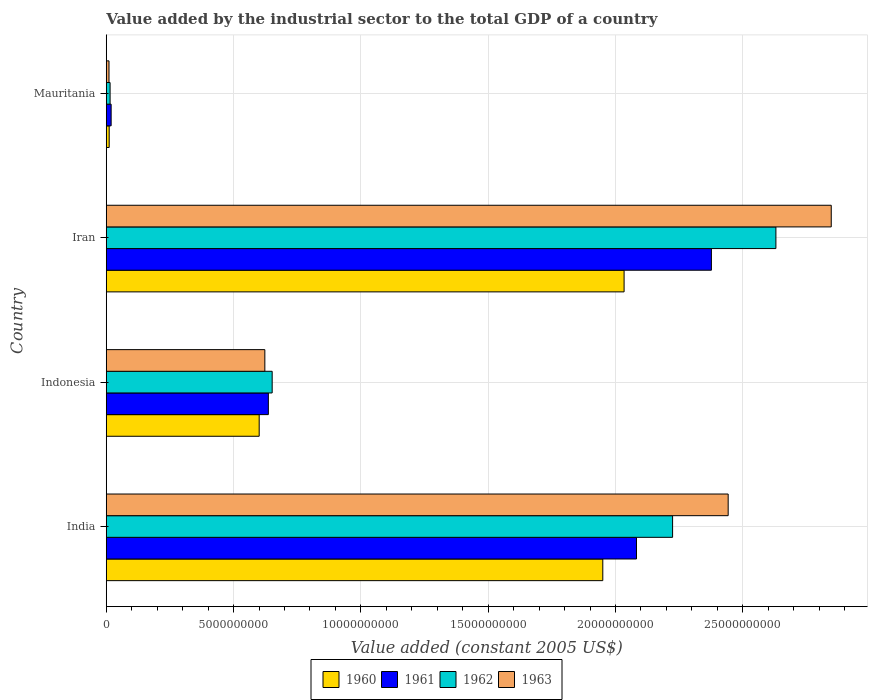Are the number of bars per tick equal to the number of legend labels?
Your response must be concise. Yes. How many bars are there on the 3rd tick from the top?
Offer a terse response. 4. How many bars are there on the 3rd tick from the bottom?
Ensure brevity in your answer.  4. What is the label of the 2nd group of bars from the top?
Give a very brief answer. Iran. In how many cases, is the number of bars for a given country not equal to the number of legend labels?
Ensure brevity in your answer.  0. What is the value added by the industrial sector in 1960 in Indonesia?
Make the answer very short. 6.01e+09. Across all countries, what is the maximum value added by the industrial sector in 1961?
Give a very brief answer. 2.38e+1. Across all countries, what is the minimum value added by the industrial sector in 1961?
Give a very brief answer. 1.92e+08. In which country was the value added by the industrial sector in 1960 maximum?
Your response must be concise. Iran. In which country was the value added by the industrial sector in 1962 minimum?
Offer a very short reply. Mauritania. What is the total value added by the industrial sector in 1962 in the graph?
Offer a very short reply. 5.52e+1. What is the difference between the value added by the industrial sector in 1960 in Indonesia and that in Iran?
Offer a very short reply. -1.43e+1. What is the difference between the value added by the industrial sector in 1960 in India and the value added by the industrial sector in 1963 in Mauritania?
Provide a succinct answer. 1.94e+1. What is the average value added by the industrial sector in 1961 per country?
Make the answer very short. 1.28e+1. What is the difference between the value added by the industrial sector in 1963 and value added by the industrial sector in 1960 in Indonesia?
Your response must be concise. 2.22e+08. In how many countries, is the value added by the industrial sector in 1963 greater than 21000000000 US$?
Your response must be concise. 2. What is the ratio of the value added by the industrial sector in 1962 in Iran to that in Mauritania?
Ensure brevity in your answer.  173.84. Is the difference between the value added by the industrial sector in 1963 in India and Indonesia greater than the difference between the value added by the industrial sector in 1960 in India and Indonesia?
Your answer should be very brief. Yes. What is the difference between the highest and the second highest value added by the industrial sector in 1963?
Make the answer very short. 4.05e+09. What is the difference between the highest and the lowest value added by the industrial sector in 1962?
Your response must be concise. 2.62e+1. In how many countries, is the value added by the industrial sector in 1963 greater than the average value added by the industrial sector in 1963 taken over all countries?
Your response must be concise. 2. Is the sum of the value added by the industrial sector in 1963 in India and Indonesia greater than the maximum value added by the industrial sector in 1961 across all countries?
Provide a short and direct response. Yes. What does the 3rd bar from the top in Indonesia represents?
Keep it short and to the point. 1961. Is it the case that in every country, the sum of the value added by the industrial sector in 1963 and value added by the industrial sector in 1961 is greater than the value added by the industrial sector in 1960?
Offer a terse response. Yes. How many countries are there in the graph?
Give a very brief answer. 4. Are the values on the major ticks of X-axis written in scientific E-notation?
Offer a terse response. No. Where does the legend appear in the graph?
Offer a terse response. Bottom center. What is the title of the graph?
Make the answer very short. Value added by the industrial sector to the total GDP of a country. What is the label or title of the X-axis?
Your answer should be very brief. Value added (constant 2005 US$). What is the Value added (constant 2005 US$) in 1960 in India?
Ensure brevity in your answer.  1.95e+1. What is the Value added (constant 2005 US$) in 1961 in India?
Offer a very short reply. 2.08e+1. What is the Value added (constant 2005 US$) in 1962 in India?
Ensure brevity in your answer.  2.22e+1. What is the Value added (constant 2005 US$) in 1963 in India?
Make the answer very short. 2.44e+1. What is the Value added (constant 2005 US$) in 1960 in Indonesia?
Keep it short and to the point. 6.01e+09. What is the Value added (constant 2005 US$) in 1961 in Indonesia?
Provide a succinct answer. 6.37e+09. What is the Value added (constant 2005 US$) in 1962 in Indonesia?
Offer a very short reply. 6.52e+09. What is the Value added (constant 2005 US$) in 1963 in Indonesia?
Keep it short and to the point. 6.23e+09. What is the Value added (constant 2005 US$) of 1960 in Iran?
Offer a very short reply. 2.03e+1. What is the Value added (constant 2005 US$) in 1961 in Iran?
Provide a short and direct response. 2.38e+1. What is the Value added (constant 2005 US$) in 1962 in Iran?
Offer a very short reply. 2.63e+1. What is the Value added (constant 2005 US$) in 1963 in Iran?
Give a very brief answer. 2.85e+1. What is the Value added (constant 2005 US$) of 1960 in Mauritania?
Your response must be concise. 1.15e+08. What is the Value added (constant 2005 US$) in 1961 in Mauritania?
Your answer should be compact. 1.92e+08. What is the Value added (constant 2005 US$) of 1962 in Mauritania?
Ensure brevity in your answer.  1.51e+08. What is the Value added (constant 2005 US$) of 1963 in Mauritania?
Offer a terse response. 1.08e+08. Across all countries, what is the maximum Value added (constant 2005 US$) in 1960?
Offer a very short reply. 2.03e+1. Across all countries, what is the maximum Value added (constant 2005 US$) of 1961?
Offer a very short reply. 2.38e+1. Across all countries, what is the maximum Value added (constant 2005 US$) in 1962?
Provide a short and direct response. 2.63e+1. Across all countries, what is the maximum Value added (constant 2005 US$) in 1963?
Offer a terse response. 2.85e+1. Across all countries, what is the minimum Value added (constant 2005 US$) of 1960?
Your answer should be compact. 1.15e+08. Across all countries, what is the minimum Value added (constant 2005 US$) in 1961?
Keep it short and to the point. 1.92e+08. Across all countries, what is the minimum Value added (constant 2005 US$) in 1962?
Your response must be concise. 1.51e+08. Across all countries, what is the minimum Value added (constant 2005 US$) of 1963?
Make the answer very short. 1.08e+08. What is the total Value added (constant 2005 US$) in 1960 in the graph?
Provide a succinct answer. 4.60e+1. What is the total Value added (constant 2005 US$) of 1961 in the graph?
Give a very brief answer. 5.12e+1. What is the total Value added (constant 2005 US$) in 1962 in the graph?
Ensure brevity in your answer.  5.52e+1. What is the total Value added (constant 2005 US$) of 1963 in the graph?
Your response must be concise. 5.92e+1. What is the difference between the Value added (constant 2005 US$) in 1960 in India and that in Indonesia?
Offer a very short reply. 1.35e+1. What is the difference between the Value added (constant 2005 US$) in 1961 in India and that in Indonesia?
Your answer should be compact. 1.45e+1. What is the difference between the Value added (constant 2005 US$) of 1962 in India and that in Indonesia?
Your response must be concise. 1.57e+1. What is the difference between the Value added (constant 2005 US$) in 1963 in India and that in Indonesia?
Provide a succinct answer. 1.82e+1. What is the difference between the Value added (constant 2005 US$) in 1960 in India and that in Iran?
Give a very brief answer. -8.36e+08. What is the difference between the Value added (constant 2005 US$) in 1961 in India and that in Iran?
Your response must be concise. -2.94e+09. What is the difference between the Value added (constant 2005 US$) of 1962 in India and that in Iran?
Offer a terse response. -4.06e+09. What is the difference between the Value added (constant 2005 US$) of 1963 in India and that in Iran?
Offer a terse response. -4.05e+09. What is the difference between the Value added (constant 2005 US$) of 1960 in India and that in Mauritania?
Provide a succinct answer. 1.94e+1. What is the difference between the Value added (constant 2005 US$) of 1961 in India and that in Mauritania?
Offer a very short reply. 2.06e+1. What is the difference between the Value added (constant 2005 US$) in 1962 in India and that in Mauritania?
Provide a succinct answer. 2.21e+1. What is the difference between the Value added (constant 2005 US$) in 1963 in India and that in Mauritania?
Make the answer very short. 2.43e+1. What is the difference between the Value added (constant 2005 US$) in 1960 in Indonesia and that in Iran?
Give a very brief answer. -1.43e+1. What is the difference between the Value added (constant 2005 US$) in 1961 in Indonesia and that in Iran?
Keep it short and to the point. -1.74e+1. What is the difference between the Value added (constant 2005 US$) in 1962 in Indonesia and that in Iran?
Keep it short and to the point. -1.98e+1. What is the difference between the Value added (constant 2005 US$) of 1963 in Indonesia and that in Iran?
Make the answer very short. -2.22e+1. What is the difference between the Value added (constant 2005 US$) of 1960 in Indonesia and that in Mauritania?
Your answer should be compact. 5.89e+09. What is the difference between the Value added (constant 2005 US$) in 1961 in Indonesia and that in Mauritania?
Provide a succinct answer. 6.17e+09. What is the difference between the Value added (constant 2005 US$) in 1962 in Indonesia and that in Mauritania?
Make the answer very short. 6.37e+09. What is the difference between the Value added (constant 2005 US$) of 1963 in Indonesia and that in Mauritania?
Your answer should be compact. 6.12e+09. What is the difference between the Value added (constant 2005 US$) in 1960 in Iran and that in Mauritania?
Provide a short and direct response. 2.02e+1. What is the difference between the Value added (constant 2005 US$) in 1961 in Iran and that in Mauritania?
Offer a very short reply. 2.36e+1. What is the difference between the Value added (constant 2005 US$) of 1962 in Iran and that in Mauritania?
Make the answer very short. 2.62e+1. What is the difference between the Value added (constant 2005 US$) of 1963 in Iran and that in Mauritania?
Make the answer very short. 2.84e+1. What is the difference between the Value added (constant 2005 US$) of 1960 in India and the Value added (constant 2005 US$) of 1961 in Indonesia?
Provide a succinct answer. 1.31e+1. What is the difference between the Value added (constant 2005 US$) in 1960 in India and the Value added (constant 2005 US$) in 1962 in Indonesia?
Make the answer very short. 1.30e+1. What is the difference between the Value added (constant 2005 US$) of 1960 in India and the Value added (constant 2005 US$) of 1963 in Indonesia?
Your answer should be compact. 1.33e+1. What is the difference between the Value added (constant 2005 US$) of 1961 in India and the Value added (constant 2005 US$) of 1962 in Indonesia?
Your answer should be very brief. 1.43e+1. What is the difference between the Value added (constant 2005 US$) in 1961 in India and the Value added (constant 2005 US$) in 1963 in Indonesia?
Ensure brevity in your answer.  1.46e+1. What is the difference between the Value added (constant 2005 US$) of 1962 in India and the Value added (constant 2005 US$) of 1963 in Indonesia?
Offer a very short reply. 1.60e+1. What is the difference between the Value added (constant 2005 US$) in 1960 in India and the Value added (constant 2005 US$) in 1961 in Iran?
Offer a very short reply. -4.27e+09. What is the difference between the Value added (constant 2005 US$) of 1960 in India and the Value added (constant 2005 US$) of 1962 in Iran?
Your answer should be compact. -6.80e+09. What is the difference between the Value added (constant 2005 US$) in 1960 in India and the Value added (constant 2005 US$) in 1963 in Iran?
Make the answer very short. -8.97e+09. What is the difference between the Value added (constant 2005 US$) in 1961 in India and the Value added (constant 2005 US$) in 1962 in Iran?
Your answer should be compact. -5.48e+09. What is the difference between the Value added (constant 2005 US$) of 1961 in India and the Value added (constant 2005 US$) of 1963 in Iran?
Give a very brief answer. -7.65e+09. What is the difference between the Value added (constant 2005 US$) of 1962 in India and the Value added (constant 2005 US$) of 1963 in Iran?
Provide a short and direct response. -6.23e+09. What is the difference between the Value added (constant 2005 US$) in 1960 in India and the Value added (constant 2005 US$) in 1961 in Mauritania?
Provide a succinct answer. 1.93e+1. What is the difference between the Value added (constant 2005 US$) in 1960 in India and the Value added (constant 2005 US$) in 1962 in Mauritania?
Ensure brevity in your answer.  1.94e+1. What is the difference between the Value added (constant 2005 US$) in 1960 in India and the Value added (constant 2005 US$) in 1963 in Mauritania?
Offer a very short reply. 1.94e+1. What is the difference between the Value added (constant 2005 US$) of 1961 in India and the Value added (constant 2005 US$) of 1962 in Mauritania?
Your response must be concise. 2.07e+1. What is the difference between the Value added (constant 2005 US$) in 1961 in India and the Value added (constant 2005 US$) in 1963 in Mauritania?
Make the answer very short. 2.07e+1. What is the difference between the Value added (constant 2005 US$) in 1962 in India and the Value added (constant 2005 US$) in 1963 in Mauritania?
Make the answer very short. 2.21e+1. What is the difference between the Value added (constant 2005 US$) of 1960 in Indonesia and the Value added (constant 2005 US$) of 1961 in Iran?
Keep it short and to the point. -1.78e+1. What is the difference between the Value added (constant 2005 US$) in 1960 in Indonesia and the Value added (constant 2005 US$) in 1962 in Iran?
Your response must be concise. -2.03e+1. What is the difference between the Value added (constant 2005 US$) in 1960 in Indonesia and the Value added (constant 2005 US$) in 1963 in Iran?
Offer a very short reply. -2.25e+1. What is the difference between the Value added (constant 2005 US$) of 1961 in Indonesia and the Value added (constant 2005 US$) of 1962 in Iran?
Ensure brevity in your answer.  -1.99e+1. What is the difference between the Value added (constant 2005 US$) in 1961 in Indonesia and the Value added (constant 2005 US$) in 1963 in Iran?
Ensure brevity in your answer.  -2.21e+1. What is the difference between the Value added (constant 2005 US$) of 1962 in Indonesia and the Value added (constant 2005 US$) of 1963 in Iran?
Keep it short and to the point. -2.20e+1. What is the difference between the Value added (constant 2005 US$) of 1960 in Indonesia and the Value added (constant 2005 US$) of 1961 in Mauritania?
Offer a very short reply. 5.81e+09. What is the difference between the Value added (constant 2005 US$) in 1960 in Indonesia and the Value added (constant 2005 US$) in 1962 in Mauritania?
Make the answer very short. 5.86e+09. What is the difference between the Value added (constant 2005 US$) of 1960 in Indonesia and the Value added (constant 2005 US$) of 1963 in Mauritania?
Ensure brevity in your answer.  5.90e+09. What is the difference between the Value added (constant 2005 US$) in 1961 in Indonesia and the Value added (constant 2005 US$) in 1962 in Mauritania?
Provide a short and direct response. 6.22e+09. What is the difference between the Value added (constant 2005 US$) in 1961 in Indonesia and the Value added (constant 2005 US$) in 1963 in Mauritania?
Make the answer very short. 6.26e+09. What is the difference between the Value added (constant 2005 US$) in 1962 in Indonesia and the Value added (constant 2005 US$) in 1963 in Mauritania?
Your response must be concise. 6.41e+09. What is the difference between the Value added (constant 2005 US$) of 1960 in Iran and the Value added (constant 2005 US$) of 1961 in Mauritania?
Your answer should be compact. 2.01e+1. What is the difference between the Value added (constant 2005 US$) of 1960 in Iran and the Value added (constant 2005 US$) of 1962 in Mauritania?
Keep it short and to the point. 2.02e+1. What is the difference between the Value added (constant 2005 US$) of 1960 in Iran and the Value added (constant 2005 US$) of 1963 in Mauritania?
Provide a short and direct response. 2.02e+1. What is the difference between the Value added (constant 2005 US$) in 1961 in Iran and the Value added (constant 2005 US$) in 1962 in Mauritania?
Ensure brevity in your answer.  2.36e+1. What is the difference between the Value added (constant 2005 US$) of 1961 in Iran and the Value added (constant 2005 US$) of 1963 in Mauritania?
Your answer should be very brief. 2.37e+1. What is the difference between the Value added (constant 2005 US$) in 1962 in Iran and the Value added (constant 2005 US$) in 1963 in Mauritania?
Give a very brief answer. 2.62e+1. What is the average Value added (constant 2005 US$) in 1960 per country?
Ensure brevity in your answer.  1.15e+1. What is the average Value added (constant 2005 US$) in 1961 per country?
Ensure brevity in your answer.  1.28e+1. What is the average Value added (constant 2005 US$) of 1962 per country?
Your response must be concise. 1.38e+1. What is the average Value added (constant 2005 US$) of 1963 per country?
Your response must be concise. 1.48e+1. What is the difference between the Value added (constant 2005 US$) in 1960 and Value added (constant 2005 US$) in 1961 in India?
Provide a succinct answer. -1.32e+09. What is the difference between the Value added (constant 2005 US$) of 1960 and Value added (constant 2005 US$) of 1962 in India?
Your answer should be very brief. -2.74e+09. What is the difference between the Value added (constant 2005 US$) of 1960 and Value added (constant 2005 US$) of 1963 in India?
Offer a very short reply. -4.92e+09. What is the difference between the Value added (constant 2005 US$) of 1961 and Value added (constant 2005 US$) of 1962 in India?
Offer a very short reply. -1.42e+09. What is the difference between the Value added (constant 2005 US$) of 1961 and Value added (constant 2005 US$) of 1963 in India?
Offer a very short reply. -3.60e+09. What is the difference between the Value added (constant 2005 US$) in 1962 and Value added (constant 2005 US$) in 1963 in India?
Your answer should be compact. -2.18e+09. What is the difference between the Value added (constant 2005 US$) in 1960 and Value added (constant 2005 US$) in 1961 in Indonesia?
Your answer should be compact. -3.60e+08. What is the difference between the Value added (constant 2005 US$) of 1960 and Value added (constant 2005 US$) of 1962 in Indonesia?
Your response must be concise. -5.10e+08. What is the difference between the Value added (constant 2005 US$) in 1960 and Value added (constant 2005 US$) in 1963 in Indonesia?
Your answer should be compact. -2.22e+08. What is the difference between the Value added (constant 2005 US$) in 1961 and Value added (constant 2005 US$) in 1962 in Indonesia?
Provide a succinct answer. -1.50e+08. What is the difference between the Value added (constant 2005 US$) in 1961 and Value added (constant 2005 US$) in 1963 in Indonesia?
Your answer should be very brief. 1.38e+08. What is the difference between the Value added (constant 2005 US$) of 1962 and Value added (constant 2005 US$) of 1963 in Indonesia?
Keep it short and to the point. 2.88e+08. What is the difference between the Value added (constant 2005 US$) in 1960 and Value added (constant 2005 US$) in 1961 in Iran?
Provide a short and direct response. -3.43e+09. What is the difference between the Value added (constant 2005 US$) in 1960 and Value added (constant 2005 US$) in 1962 in Iran?
Keep it short and to the point. -5.96e+09. What is the difference between the Value added (constant 2005 US$) of 1960 and Value added (constant 2005 US$) of 1963 in Iran?
Ensure brevity in your answer.  -8.14e+09. What is the difference between the Value added (constant 2005 US$) of 1961 and Value added (constant 2005 US$) of 1962 in Iran?
Keep it short and to the point. -2.53e+09. What is the difference between the Value added (constant 2005 US$) in 1961 and Value added (constant 2005 US$) in 1963 in Iran?
Offer a terse response. -4.71e+09. What is the difference between the Value added (constant 2005 US$) of 1962 and Value added (constant 2005 US$) of 1963 in Iran?
Make the answer very short. -2.17e+09. What is the difference between the Value added (constant 2005 US$) in 1960 and Value added (constant 2005 US$) in 1961 in Mauritania?
Provide a succinct answer. -7.68e+07. What is the difference between the Value added (constant 2005 US$) of 1960 and Value added (constant 2005 US$) of 1962 in Mauritania?
Your response must be concise. -3.59e+07. What is the difference between the Value added (constant 2005 US$) in 1960 and Value added (constant 2005 US$) in 1963 in Mauritania?
Make the answer very short. 7.13e+06. What is the difference between the Value added (constant 2005 US$) of 1961 and Value added (constant 2005 US$) of 1962 in Mauritania?
Offer a very short reply. 4.09e+07. What is the difference between the Value added (constant 2005 US$) in 1961 and Value added (constant 2005 US$) in 1963 in Mauritania?
Give a very brief answer. 8.39e+07. What is the difference between the Value added (constant 2005 US$) in 1962 and Value added (constant 2005 US$) in 1963 in Mauritania?
Provide a short and direct response. 4.31e+07. What is the ratio of the Value added (constant 2005 US$) in 1960 in India to that in Indonesia?
Ensure brevity in your answer.  3.25. What is the ratio of the Value added (constant 2005 US$) in 1961 in India to that in Indonesia?
Make the answer very short. 3.27. What is the ratio of the Value added (constant 2005 US$) of 1962 in India to that in Indonesia?
Offer a terse response. 3.41. What is the ratio of the Value added (constant 2005 US$) of 1963 in India to that in Indonesia?
Provide a succinct answer. 3.92. What is the ratio of the Value added (constant 2005 US$) of 1960 in India to that in Iran?
Offer a terse response. 0.96. What is the ratio of the Value added (constant 2005 US$) of 1961 in India to that in Iran?
Your answer should be very brief. 0.88. What is the ratio of the Value added (constant 2005 US$) in 1962 in India to that in Iran?
Ensure brevity in your answer.  0.85. What is the ratio of the Value added (constant 2005 US$) in 1963 in India to that in Iran?
Offer a very short reply. 0.86. What is the ratio of the Value added (constant 2005 US$) in 1960 in India to that in Mauritania?
Your answer should be very brief. 169.07. What is the ratio of the Value added (constant 2005 US$) of 1961 in India to that in Mauritania?
Your answer should be compact. 108.39. What is the ratio of the Value added (constant 2005 US$) of 1962 in India to that in Mauritania?
Your answer should be compact. 147.02. What is the ratio of the Value added (constant 2005 US$) of 1963 in India to that in Mauritania?
Your answer should be compact. 225.7. What is the ratio of the Value added (constant 2005 US$) of 1960 in Indonesia to that in Iran?
Offer a terse response. 0.3. What is the ratio of the Value added (constant 2005 US$) in 1961 in Indonesia to that in Iran?
Offer a very short reply. 0.27. What is the ratio of the Value added (constant 2005 US$) of 1962 in Indonesia to that in Iran?
Offer a terse response. 0.25. What is the ratio of the Value added (constant 2005 US$) of 1963 in Indonesia to that in Iran?
Provide a short and direct response. 0.22. What is the ratio of the Value added (constant 2005 US$) of 1960 in Indonesia to that in Mauritania?
Give a very brief answer. 52.07. What is the ratio of the Value added (constant 2005 US$) of 1961 in Indonesia to that in Mauritania?
Ensure brevity in your answer.  33.14. What is the ratio of the Value added (constant 2005 US$) of 1962 in Indonesia to that in Mauritania?
Your response must be concise. 43.07. What is the ratio of the Value added (constant 2005 US$) in 1963 in Indonesia to that in Mauritania?
Offer a terse response. 57.56. What is the ratio of the Value added (constant 2005 US$) in 1960 in Iran to that in Mauritania?
Provide a succinct answer. 176.32. What is the ratio of the Value added (constant 2005 US$) in 1961 in Iran to that in Mauritania?
Offer a terse response. 123.7. What is the ratio of the Value added (constant 2005 US$) in 1962 in Iran to that in Mauritania?
Provide a succinct answer. 173.84. What is the ratio of the Value added (constant 2005 US$) in 1963 in Iran to that in Mauritania?
Keep it short and to the point. 263.11. What is the difference between the highest and the second highest Value added (constant 2005 US$) of 1960?
Offer a terse response. 8.36e+08. What is the difference between the highest and the second highest Value added (constant 2005 US$) of 1961?
Provide a succinct answer. 2.94e+09. What is the difference between the highest and the second highest Value added (constant 2005 US$) in 1962?
Keep it short and to the point. 4.06e+09. What is the difference between the highest and the second highest Value added (constant 2005 US$) in 1963?
Your response must be concise. 4.05e+09. What is the difference between the highest and the lowest Value added (constant 2005 US$) of 1960?
Keep it short and to the point. 2.02e+1. What is the difference between the highest and the lowest Value added (constant 2005 US$) in 1961?
Your answer should be very brief. 2.36e+1. What is the difference between the highest and the lowest Value added (constant 2005 US$) in 1962?
Your answer should be compact. 2.62e+1. What is the difference between the highest and the lowest Value added (constant 2005 US$) of 1963?
Ensure brevity in your answer.  2.84e+1. 